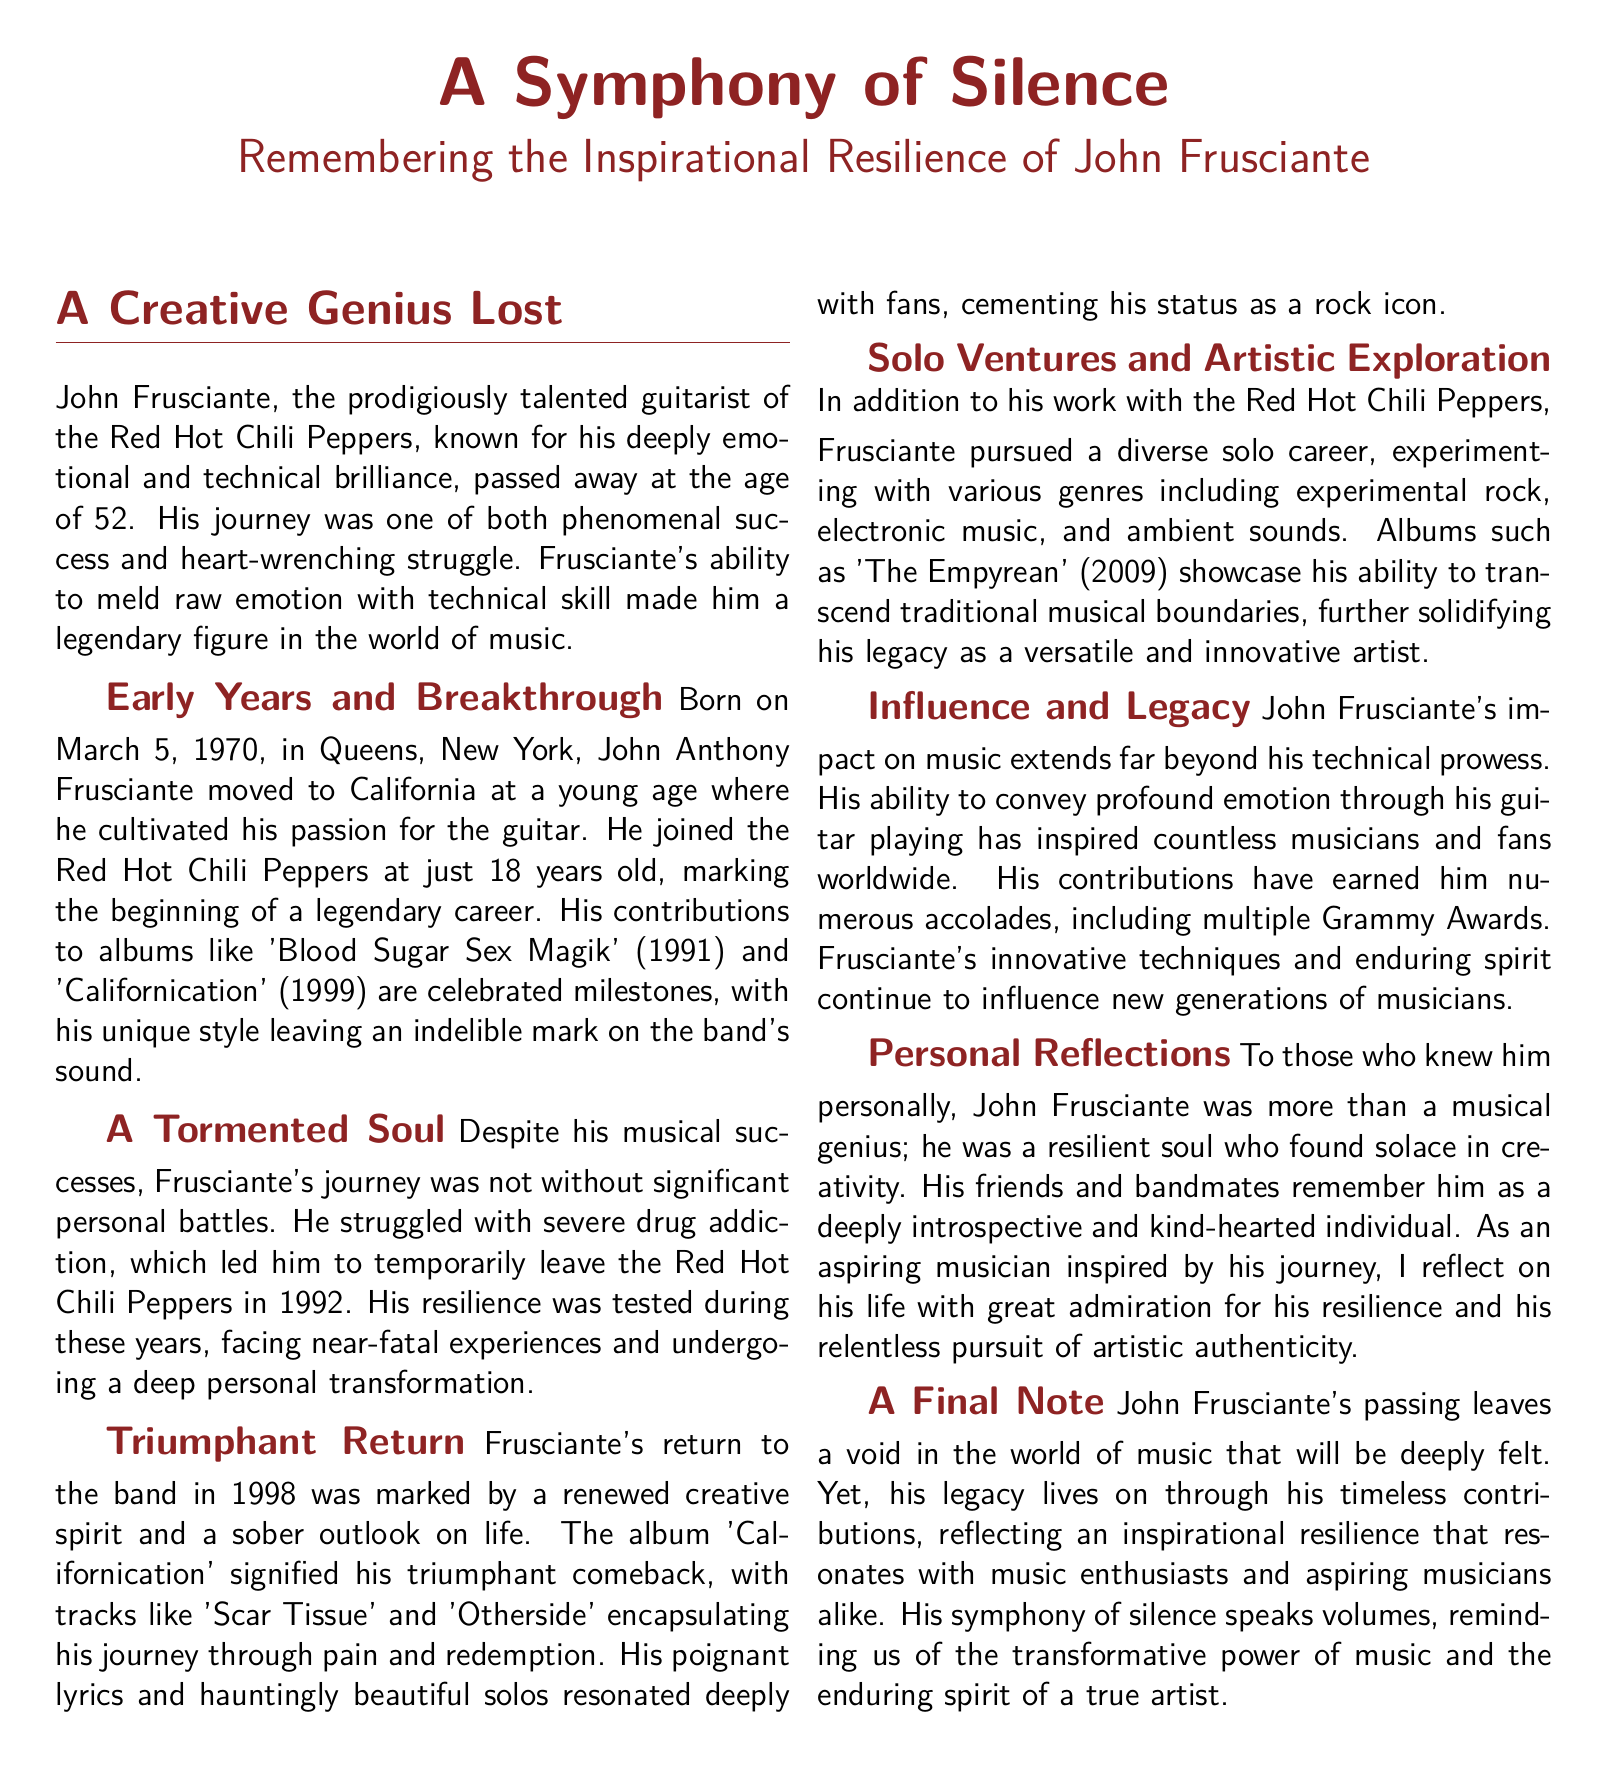What is the age of John Frusciante at the time of his passing? The document states that John Frusciante passed away at the age of 52.
Answer: 52 In which band was John Frusciante a guitarist? The obituary mentions that he was the guitarist of the Red Hot Chili Peppers.
Answer: Red Hot Chili Peppers What year did John Frusciante join the band? The document states that he joined the band at just 18 years old, implying he joined in 1988.
Answer: 1988 What significant life event occurred for Frusciante in 1992? The document notes that he struggled with severe drug addiction and temporarily left the Red Hot Chili Peppers in 1992.
Answer: Left the band What was the title of the album that marked Frusciante's return to the band? The obituary mentions that 'Californication' signified his triumphant comeback.
Answer: Californication What genre of music did Frusciante explore in his solo career? The document mentions that he experimented with electronic music and ambient sounds among other genres.
Answer: Electronic music How many Grammy Awards did John Frusciante earn throughout his career? The document refers to him earning multiple Grammy Awards, without specifying a number.
Answer: Multiple Which song is mentioned as encapsulating Frusciante's journey through pain and redemption? The obituary highlights 'Scar Tissue' as one of the tracks representing this journey.
Answer: Scar Tissue What does the document suggest about Frusciante's influence on future musicians? It states that his innovative techniques and enduring spirit continue to influence new generations of musicians.
Answer: Enduring spirit 